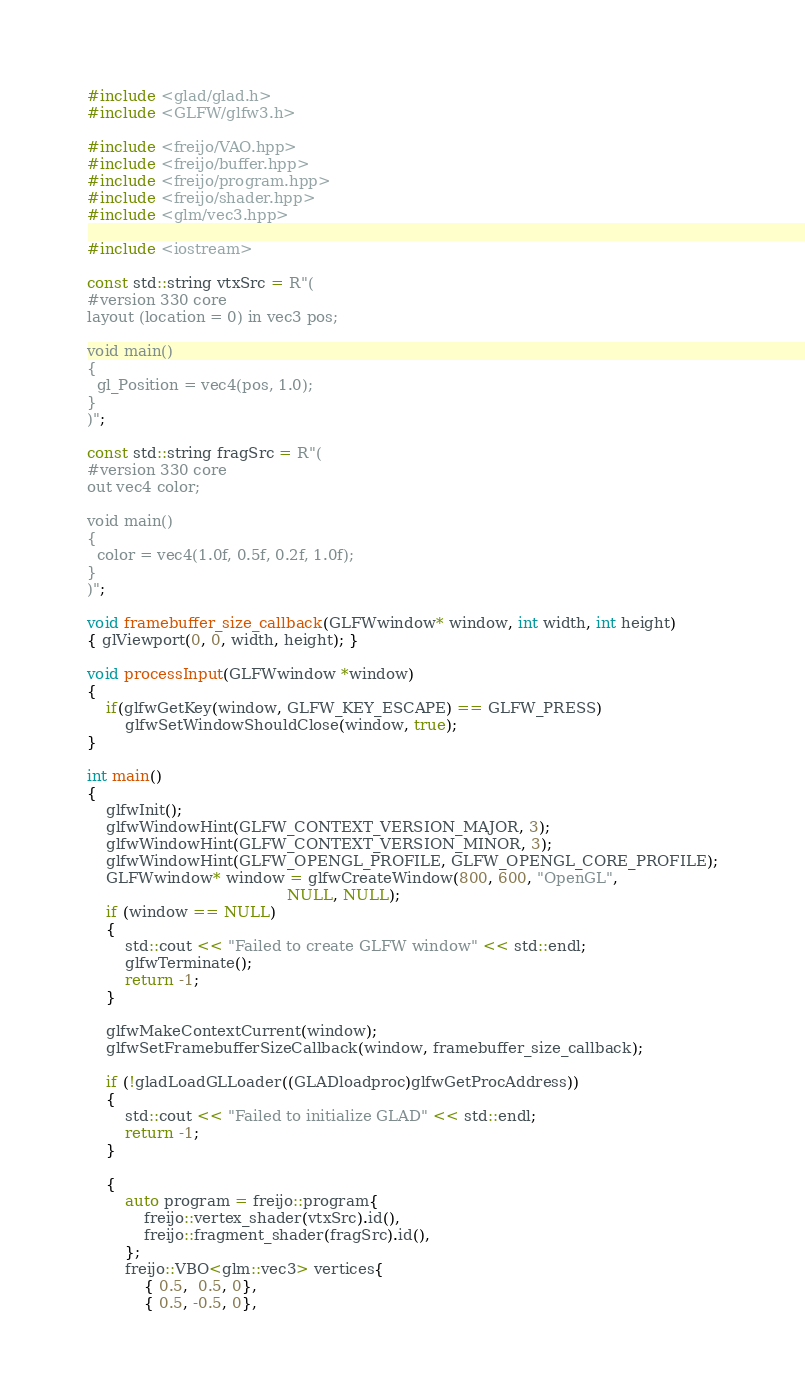<code> <loc_0><loc_0><loc_500><loc_500><_C++_>#include <glad/glad.h>
#include <GLFW/glfw3.h>

#include <freijo/VAO.hpp>
#include <freijo/buffer.hpp>
#include <freijo/program.hpp>
#include <freijo/shader.hpp>
#include <glm/vec3.hpp>

#include <iostream>

const std::string vtxSrc = R"(
#version 330 core
layout (location = 0) in vec3 pos;

void main()
{
  gl_Position = vec4(pos, 1.0);
}
)";

const std::string fragSrc = R"(
#version 330 core
out vec4 color;

void main()
{
  color = vec4(1.0f, 0.5f, 0.2f, 1.0f);
}
)";

void framebuffer_size_callback(GLFWwindow* window, int width, int height)
{ glViewport(0, 0, width, height); }

void processInput(GLFWwindow *window)
{
    if(glfwGetKey(window, GLFW_KEY_ESCAPE) == GLFW_PRESS)
        glfwSetWindowShouldClose(window, true);
}

int main()
{
    glfwInit();
    glfwWindowHint(GLFW_CONTEXT_VERSION_MAJOR, 3);
    glfwWindowHint(GLFW_CONTEXT_VERSION_MINOR, 3);
    glfwWindowHint(GLFW_OPENGL_PROFILE, GLFW_OPENGL_CORE_PROFILE);
    GLFWwindow* window = glfwCreateWindow(800, 600, "OpenGL",
                                          NULL, NULL);
    if (window == NULL)
    {
        std::cout << "Failed to create GLFW window" << std::endl;
        glfwTerminate();
        return -1;
    }
    
    glfwMakeContextCurrent(window);
    glfwSetFramebufferSizeCallback(window, framebuffer_size_callback);
    
    if (!gladLoadGLLoader((GLADloadproc)glfwGetProcAddress))
    {
        std::cout << "Failed to initialize GLAD" << std::endl;
        return -1;
    }

    {
        auto program = freijo::program{
            freijo::vertex_shader(vtxSrc).id(),
            freijo::fragment_shader(fragSrc).id(),
        };
        freijo::VBO<glm::vec3> vertices{
            { 0.5,  0.5, 0},
            { 0.5, -0.5, 0},</code> 